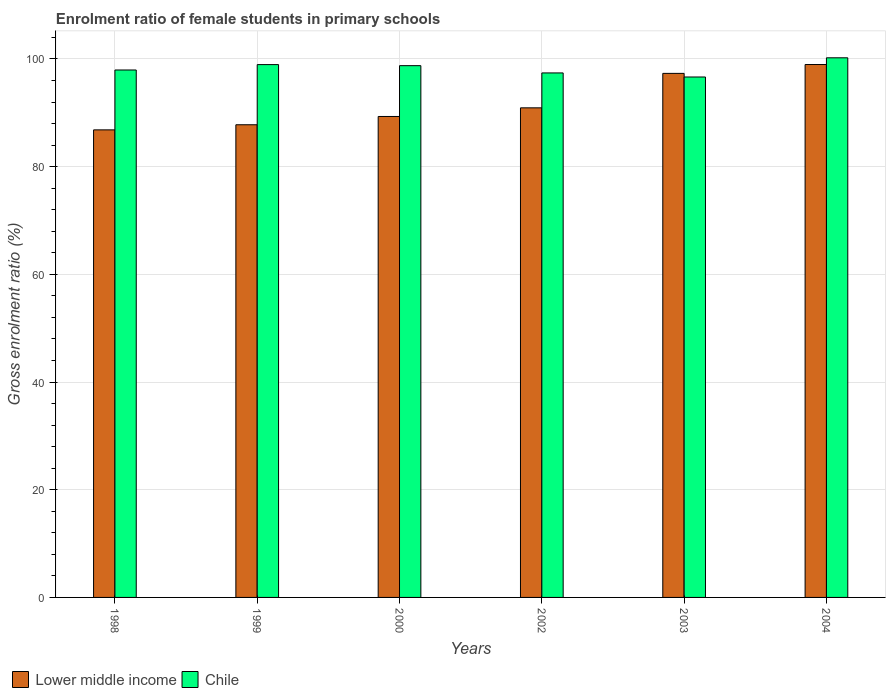How many groups of bars are there?
Your answer should be compact. 6. How many bars are there on the 6th tick from the right?
Give a very brief answer. 2. In how many cases, is the number of bars for a given year not equal to the number of legend labels?
Your answer should be very brief. 0. What is the enrolment ratio of female students in primary schools in Chile in 2004?
Your answer should be very brief. 100.22. Across all years, what is the maximum enrolment ratio of female students in primary schools in Chile?
Give a very brief answer. 100.22. Across all years, what is the minimum enrolment ratio of female students in primary schools in Chile?
Make the answer very short. 96.66. In which year was the enrolment ratio of female students in primary schools in Lower middle income maximum?
Make the answer very short. 2004. What is the total enrolment ratio of female students in primary schools in Chile in the graph?
Provide a succinct answer. 589.96. What is the difference between the enrolment ratio of female students in primary schools in Chile in 2002 and that in 2003?
Ensure brevity in your answer.  0.75. What is the difference between the enrolment ratio of female students in primary schools in Lower middle income in 2000 and the enrolment ratio of female students in primary schools in Chile in 2004?
Your response must be concise. -10.9. What is the average enrolment ratio of female students in primary schools in Chile per year?
Ensure brevity in your answer.  98.33. In the year 1999, what is the difference between the enrolment ratio of female students in primary schools in Lower middle income and enrolment ratio of female students in primary schools in Chile?
Your answer should be compact. -11.17. What is the ratio of the enrolment ratio of female students in primary schools in Lower middle income in 1999 to that in 2003?
Provide a short and direct response. 0.9. Is the difference between the enrolment ratio of female students in primary schools in Lower middle income in 1999 and 2004 greater than the difference between the enrolment ratio of female students in primary schools in Chile in 1999 and 2004?
Your response must be concise. No. What is the difference between the highest and the second highest enrolment ratio of female students in primary schools in Chile?
Give a very brief answer. 1.26. What is the difference between the highest and the lowest enrolment ratio of female students in primary schools in Chile?
Keep it short and to the point. 3.56. In how many years, is the enrolment ratio of female students in primary schools in Chile greater than the average enrolment ratio of female students in primary schools in Chile taken over all years?
Make the answer very short. 3. Is the sum of the enrolment ratio of female students in primary schools in Chile in 1998 and 2002 greater than the maximum enrolment ratio of female students in primary schools in Lower middle income across all years?
Offer a very short reply. Yes. What does the 1st bar from the left in 1998 represents?
Offer a terse response. Lower middle income. What is the difference between two consecutive major ticks on the Y-axis?
Offer a very short reply. 20. Are the values on the major ticks of Y-axis written in scientific E-notation?
Your answer should be compact. No. Does the graph contain grids?
Make the answer very short. Yes. Where does the legend appear in the graph?
Your answer should be compact. Bottom left. How many legend labels are there?
Provide a short and direct response. 2. What is the title of the graph?
Ensure brevity in your answer.  Enrolment ratio of female students in primary schools. What is the Gross enrolment ratio (%) of Lower middle income in 1998?
Ensure brevity in your answer.  86.84. What is the Gross enrolment ratio (%) in Chile in 1998?
Make the answer very short. 97.96. What is the Gross enrolment ratio (%) in Lower middle income in 1999?
Provide a succinct answer. 87.79. What is the Gross enrolment ratio (%) in Chile in 1999?
Your response must be concise. 98.96. What is the Gross enrolment ratio (%) in Lower middle income in 2000?
Keep it short and to the point. 89.32. What is the Gross enrolment ratio (%) in Chile in 2000?
Offer a terse response. 98.76. What is the Gross enrolment ratio (%) of Lower middle income in 2002?
Give a very brief answer. 90.93. What is the Gross enrolment ratio (%) in Chile in 2002?
Your response must be concise. 97.41. What is the Gross enrolment ratio (%) of Lower middle income in 2003?
Your answer should be compact. 97.33. What is the Gross enrolment ratio (%) in Chile in 2003?
Provide a short and direct response. 96.66. What is the Gross enrolment ratio (%) of Lower middle income in 2004?
Make the answer very short. 98.97. What is the Gross enrolment ratio (%) in Chile in 2004?
Your answer should be compact. 100.22. Across all years, what is the maximum Gross enrolment ratio (%) of Lower middle income?
Keep it short and to the point. 98.97. Across all years, what is the maximum Gross enrolment ratio (%) in Chile?
Provide a short and direct response. 100.22. Across all years, what is the minimum Gross enrolment ratio (%) of Lower middle income?
Provide a short and direct response. 86.84. Across all years, what is the minimum Gross enrolment ratio (%) of Chile?
Make the answer very short. 96.66. What is the total Gross enrolment ratio (%) of Lower middle income in the graph?
Your answer should be very brief. 551.17. What is the total Gross enrolment ratio (%) of Chile in the graph?
Your answer should be very brief. 589.96. What is the difference between the Gross enrolment ratio (%) of Lower middle income in 1998 and that in 1999?
Give a very brief answer. -0.95. What is the difference between the Gross enrolment ratio (%) in Chile in 1998 and that in 1999?
Provide a short and direct response. -1. What is the difference between the Gross enrolment ratio (%) of Lower middle income in 1998 and that in 2000?
Give a very brief answer. -2.49. What is the difference between the Gross enrolment ratio (%) of Chile in 1998 and that in 2000?
Make the answer very short. -0.8. What is the difference between the Gross enrolment ratio (%) in Lower middle income in 1998 and that in 2002?
Your answer should be very brief. -4.09. What is the difference between the Gross enrolment ratio (%) in Chile in 1998 and that in 2002?
Offer a very short reply. 0.55. What is the difference between the Gross enrolment ratio (%) of Lower middle income in 1998 and that in 2003?
Offer a terse response. -10.49. What is the difference between the Gross enrolment ratio (%) in Chile in 1998 and that in 2003?
Provide a succinct answer. 1.3. What is the difference between the Gross enrolment ratio (%) of Lower middle income in 1998 and that in 2004?
Offer a very short reply. -12.14. What is the difference between the Gross enrolment ratio (%) in Chile in 1998 and that in 2004?
Provide a short and direct response. -2.26. What is the difference between the Gross enrolment ratio (%) in Lower middle income in 1999 and that in 2000?
Your response must be concise. -1.54. What is the difference between the Gross enrolment ratio (%) of Chile in 1999 and that in 2000?
Provide a succinct answer. 0.2. What is the difference between the Gross enrolment ratio (%) of Lower middle income in 1999 and that in 2002?
Your answer should be compact. -3.14. What is the difference between the Gross enrolment ratio (%) of Chile in 1999 and that in 2002?
Your answer should be very brief. 1.55. What is the difference between the Gross enrolment ratio (%) in Lower middle income in 1999 and that in 2003?
Offer a terse response. -9.54. What is the difference between the Gross enrolment ratio (%) of Chile in 1999 and that in 2003?
Your answer should be compact. 2.3. What is the difference between the Gross enrolment ratio (%) of Lower middle income in 1999 and that in 2004?
Offer a very short reply. -11.19. What is the difference between the Gross enrolment ratio (%) in Chile in 1999 and that in 2004?
Give a very brief answer. -1.26. What is the difference between the Gross enrolment ratio (%) of Lower middle income in 2000 and that in 2002?
Provide a succinct answer. -1.6. What is the difference between the Gross enrolment ratio (%) in Chile in 2000 and that in 2002?
Your response must be concise. 1.35. What is the difference between the Gross enrolment ratio (%) of Lower middle income in 2000 and that in 2003?
Your answer should be compact. -8. What is the difference between the Gross enrolment ratio (%) in Chile in 2000 and that in 2003?
Make the answer very short. 2.11. What is the difference between the Gross enrolment ratio (%) in Lower middle income in 2000 and that in 2004?
Your answer should be very brief. -9.65. What is the difference between the Gross enrolment ratio (%) of Chile in 2000 and that in 2004?
Provide a short and direct response. -1.46. What is the difference between the Gross enrolment ratio (%) in Lower middle income in 2002 and that in 2003?
Your response must be concise. -6.4. What is the difference between the Gross enrolment ratio (%) of Chile in 2002 and that in 2003?
Offer a terse response. 0.76. What is the difference between the Gross enrolment ratio (%) in Lower middle income in 2002 and that in 2004?
Offer a very short reply. -8.05. What is the difference between the Gross enrolment ratio (%) of Chile in 2002 and that in 2004?
Your answer should be compact. -2.81. What is the difference between the Gross enrolment ratio (%) in Lower middle income in 2003 and that in 2004?
Make the answer very short. -1.65. What is the difference between the Gross enrolment ratio (%) in Chile in 2003 and that in 2004?
Offer a terse response. -3.56. What is the difference between the Gross enrolment ratio (%) of Lower middle income in 1998 and the Gross enrolment ratio (%) of Chile in 1999?
Keep it short and to the point. -12.12. What is the difference between the Gross enrolment ratio (%) of Lower middle income in 1998 and the Gross enrolment ratio (%) of Chile in 2000?
Ensure brevity in your answer.  -11.93. What is the difference between the Gross enrolment ratio (%) in Lower middle income in 1998 and the Gross enrolment ratio (%) in Chile in 2002?
Offer a very short reply. -10.57. What is the difference between the Gross enrolment ratio (%) in Lower middle income in 1998 and the Gross enrolment ratio (%) in Chile in 2003?
Give a very brief answer. -9.82. What is the difference between the Gross enrolment ratio (%) of Lower middle income in 1998 and the Gross enrolment ratio (%) of Chile in 2004?
Offer a terse response. -13.38. What is the difference between the Gross enrolment ratio (%) of Lower middle income in 1999 and the Gross enrolment ratio (%) of Chile in 2000?
Keep it short and to the point. -10.98. What is the difference between the Gross enrolment ratio (%) of Lower middle income in 1999 and the Gross enrolment ratio (%) of Chile in 2002?
Make the answer very short. -9.62. What is the difference between the Gross enrolment ratio (%) in Lower middle income in 1999 and the Gross enrolment ratio (%) in Chile in 2003?
Your answer should be very brief. -8.87. What is the difference between the Gross enrolment ratio (%) of Lower middle income in 1999 and the Gross enrolment ratio (%) of Chile in 2004?
Your response must be concise. -12.43. What is the difference between the Gross enrolment ratio (%) of Lower middle income in 2000 and the Gross enrolment ratio (%) of Chile in 2002?
Your answer should be compact. -8.09. What is the difference between the Gross enrolment ratio (%) in Lower middle income in 2000 and the Gross enrolment ratio (%) in Chile in 2003?
Your answer should be compact. -7.33. What is the difference between the Gross enrolment ratio (%) in Lower middle income in 2000 and the Gross enrolment ratio (%) in Chile in 2004?
Give a very brief answer. -10.9. What is the difference between the Gross enrolment ratio (%) in Lower middle income in 2002 and the Gross enrolment ratio (%) in Chile in 2003?
Provide a short and direct response. -5.73. What is the difference between the Gross enrolment ratio (%) in Lower middle income in 2002 and the Gross enrolment ratio (%) in Chile in 2004?
Provide a succinct answer. -9.29. What is the difference between the Gross enrolment ratio (%) of Lower middle income in 2003 and the Gross enrolment ratio (%) of Chile in 2004?
Keep it short and to the point. -2.89. What is the average Gross enrolment ratio (%) in Lower middle income per year?
Your answer should be very brief. 91.86. What is the average Gross enrolment ratio (%) in Chile per year?
Provide a succinct answer. 98.33. In the year 1998, what is the difference between the Gross enrolment ratio (%) of Lower middle income and Gross enrolment ratio (%) of Chile?
Your answer should be very brief. -11.12. In the year 1999, what is the difference between the Gross enrolment ratio (%) in Lower middle income and Gross enrolment ratio (%) in Chile?
Your answer should be compact. -11.17. In the year 2000, what is the difference between the Gross enrolment ratio (%) of Lower middle income and Gross enrolment ratio (%) of Chile?
Offer a very short reply. -9.44. In the year 2002, what is the difference between the Gross enrolment ratio (%) in Lower middle income and Gross enrolment ratio (%) in Chile?
Make the answer very short. -6.48. In the year 2003, what is the difference between the Gross enrolment ratio (%) in Lower middle income and Gross enrolment ratio (%) in Chile?
Your answer should be compact. 0.67. In the year 2004, what is the difference between the Gross enrolment ratio (%) in Lower middle income and Gross enrolment ratio (%) in Chile?
Your answer should be very brief. -1.25. What is the ratio of the Gross enrolment ratio (%) of Lower middle income in 1998 to that in 1999?
Provide a succinct answer. 0.99. What is the ratio of the Gross enrolment ratio (%) in Chile in 1998 to that in 1999?
Make the answer very short. 0.99. What is the ratio of the Gross enrolment ratio (%) of Lower middle income in 1998 to that in 2000?
Give a very brief answer. 0.97. What is the ratio of the Gross enrolment ratio (%) of Lower middle income in 1998 to that in 2002?
Offer a terse response. 0.95. What is the ratio of the Gross enrolment ratio (%) of Chile in 1998 to that in 2002?
Your answer should be very brief. 1.01. What is the ratio of the Gross enrolment ratio (%) in Lower middle income in 1998 to that in 2003?
Provide a succinct answer. 0.89. What is the ratio of the Gross enrolment ratio (%) in Chile in 1998 to that in 2003?
Provide a succinct answer. 1.01. What is the ratio of the Gross enrolment ratio (%) of Lower middle income in 1998 to that in 2004?
Provide a succinct answer. 0.88. What is the ratio of the Gross enrolment ratio (%) in Chile in 1998 to that in 2004?
Offer a terse response. 0.98. What is the ratio of the Gross enrolment ratio (%) in Lower middle income in 1999 to that in 2000?
Provide a short and direct response. 0.98. What is the ratio of the Gross enrolment ratio (%) in Lower middle income in 1999 to that in 2002?
Give a very brief answer. 0.97. What is the ratio of the Gross enrolment ratio (%) in Chile in 1999 to that in 2002?
Keep it short and to the point. 1.02. What is the ratio of the Gross enrolment ratio (%) in Lower middle income in 1999 to that in 2003?
Ensure brevity in your answer.  0.9. What is the ratio of the Gross enrolment ratio (%) of Chile in 1999 to that in 2003?
Your answer should be very brief. 1.02. What is the ratio of the Gross enrolment ratio (%) in Lower middle income in 1999 to that in 2004?
Your answer should be very brief. 0.89. What is the ratio of the Gross enrolment ratio (%) in Chile in 1999 to that in 2004?
Offer a terse response. 0.99. What is the ratio of the Gross enrolment ratio (%) in Lower middle income in 2000 to that in 2002?
Your response must be concise. 0.98. What is the ratio of the Gross enrolment ratio (%) in Chile in 2000 to that in 2002?
Offer a terse response. 1.01. What is the ratio of the Gross enrolment ratio (%) of Lower middle income in 2000 to that in 2003?
Make the answer very short. 0.92. What is the ratio of the Gross enrolment ratio (%) in Chile in 2000 to that in 2003?
Give a very brief answer. 1.02. What is the ratio of the Gross enrolment ratio (%) in Lower middle income in 2000 to that in 2004?
Give a very brief answer. 0.9. What is the ratio of the Gross enrolment ratio (%) of Chile in 2000 to that in 2004?
Provide a short and direct response. 0.99. What is the ratio of the Gross enrolment ratio (%) of Lower middle income in 2002 to that in 2003?
Your response must be concise. 0.93. What is the ratio of the Gross enrolment ratio (%) in Lower middle income in 2002 to that in 2004?
Ensure brevity in your answer.  0.92. What is the ratio of the Gross enrolment ratio (%) of Lower middle income in 2003 to that in 2004?
Your answer should be compact. 0.98. What is the ratio of the Gross enrolment ratio (%) of Chile in 2003 to that in 2004?
Provide a succinct answer. 0.96. What is the difference between the highest and the second highest Gross enrolment ratio (%) of Lower middle income?
Ensure brevity in your answer.  1.65. What is the difference between the highest and the second highest Gross enrolment ratio (%) in Chile?
Offer a very short reply. 1.26. What is the difference between the highest and the lowest Gross enrolment ratio (%) of Lower middle income?
Provide a succinct answer. 12.14. What is the difference between the highest and the lowest Gross enrolment ratio (%) in Chile?
Your answer should be compact. 3.56. 